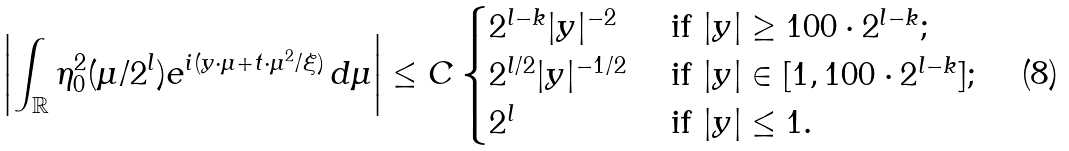Convert formula to latex. <formula><loc_0><loc_0><loc_500><loc_500>\left | \int _ { \mathbb { R } } \eta _ { 0 } ^ { 2 } ( \mu / 2 ^ { l } ) e ^ { i ( y \cdot \mu + t \cdot \mu ^ { 2 } / \xi ) } \, d \mu \right | \leq C \begin{cases} 2 ^ { l - k } | y | ^ { - 2 } & \text { if } | y | \geq 1 0 0 \cdot 2 ^ { l - k } ; \\ 2 ^ { l / 2 } | y | ^ { - 1 / 2 } & \text { if } | y | \in [ 1 , 1 0 0 \cdot 2 ^ { l - k } ] ; \\ 2 ^ { l } & \text { if } | y | \leq 1 . \end{cases}</formula> 